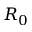<formula> <loc_0><loc_0><loc_500><loc_500>R _ { 0 }</formula> 